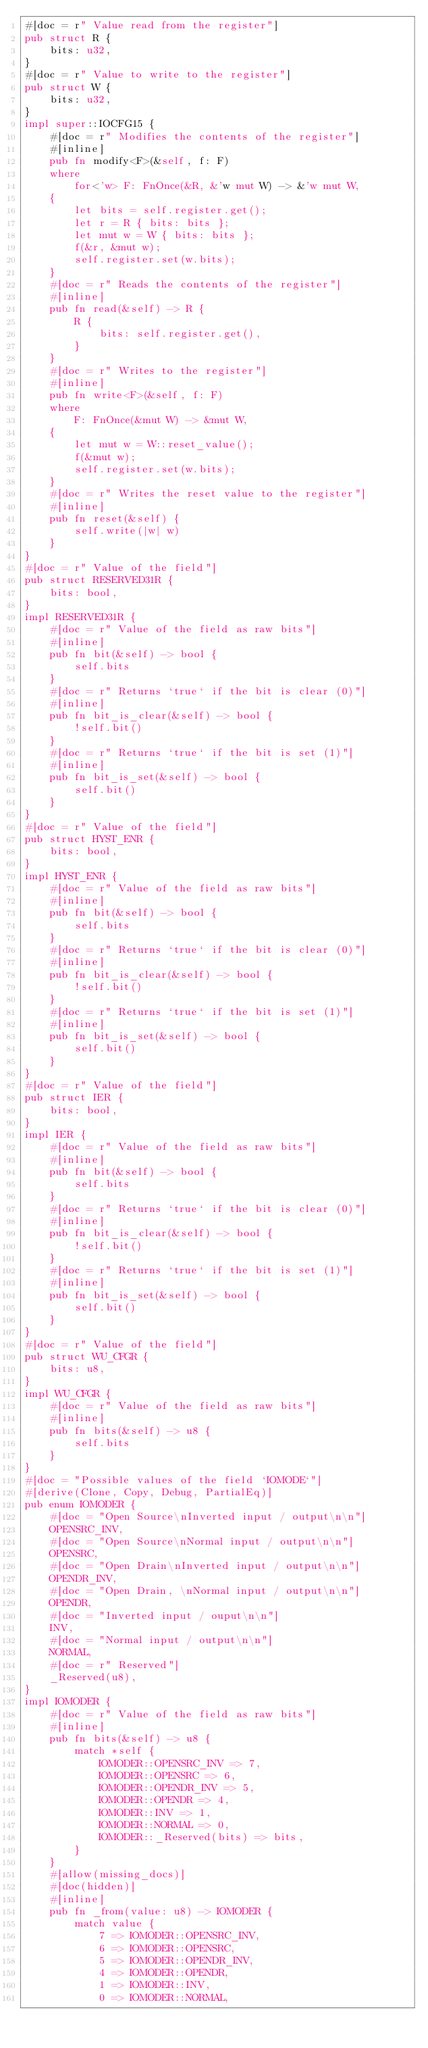<code> <loc_0><loc_0><loc_500><loc_500><_Rust_>#[doc = r" Value read from the register"]
pub struct R {
    bits: u32,
}
#[doc = r" Value to write to the register"]
pub struct W {
    bits: u32,
}
impl super::IOCFG15 {
    #[doc = r" Modifies the contents of the register"]
    #[inline]
    pub fn modify<F>(&self, f: F)
    where
        for<'w> F: FnOnce(&R, &'w mut W) -> &'w mut W,
    {
        let bits = self.register.get();
        let r = R { bits: bits };
        let mut w = W { bits: bits };
        f(&r, &mut w);
        self.register.set(w.bits);
    }
    #[doc = r" Reads the contents of the register"]
    #[inline]
    pub fn read(&self) -> R {
        R {
            bits: self.register.get(),
        }
    }
    #[doc = r" Writes to the register"]
    #[inline]
    pub fn write<F>(&self, f: F)
    where
        F: FnOnce(&mut W) -> &mut W,
    {
        let mut w = W::reset_value();
        f(&mut w);
        self.register.set(w.bits);
    }
    #[doc = r" Writes the reset value to the register"]
    #[inline]
    pub fn reset(&self) {
        self.write(|w| w)
    }
}
#[doc = r" Value of the field"]
pub struct RESERVED31R {
    bits: bool,
}
impl RESERVED31R {
    #[doc = r" Value of the field as raw bits"]
    #[inline]
    pub fn bit(&self) -> bool {
        self.bits
    }
    #[doc = r" Returns `true` if the bit is clear (0)"]
    #[inline]
    pub fn bit_is_clear(&self) -> bool {
        !self.bit()
    }
    #[doc = r" Returns `true` if the bit is set (1)"]
    #[inline]
    pub fn bit_is_set(&self) -> bool {
        self.bit()
    }
}
#[doc = r" Value of the field"]
pub struct HYST_ENR {
    bits: bool,
}
impl HYST_ENR {
    #[doc = r" Value of the field as raw bits"]
    #[inline]
    pub fn bit(&self) -> bool {
        self.bits
    }
    #[doc = r" Returns `true` if the bit is clear (0)"]
    #[inline]
    pub fn bit_is_clear(&self) -> bool {
        !self.bit()
    }
    #[doc = r" Returns `true` if the bit is set (1)"]
    #[inline]
    pub fn bit_is_set(&self) -> bool {
        self.bit()
    }
}
#[doc = r" Value of the field"]
pub struct IER {
    bits: bool,
}
impl IER {
    #[doc = r" Value of the field as raw bits"]
    #[inline]
    pub fn bit(&self) -> bool {
        self.bits
    }
    #[doc = r" Returns `true` if the bit is clear (0)"]
    #[inline]
    pub fn bit_is_clear(&self) -> bool {
        !self.bit()
    }
    #[doc = r" Returns `true` if the bit is set (1)"]
    #[inline]
    pub fn bit_is_set(&self) -> bool {
        self.bit()
    }
}
#[doc = r" Value of the field"]
pub struct WU_CFGR {
    bits: u8,
}
impl WU_CFGR {
    #[doc = r" Value of the field as raw bits"]
    #[inline]
    pub fn bits(&self) -> u8 {
        self.bits
    }
}
#[doc = "Possible values of the field `IOMODE`"]
#[derive(Clone, Copy, Debug, PartialEq)]
pub enum IOMODER {
    #[doc = "Open Source\nInverted input / output\n\n"]
    OPENSRC_INV,
    #[doc = "Open Source\nNormal input / output\n\n"]
    OPENSRC,
    #[doc = "Open Drain\nInverted input / output\n\n"]
    OPENDR_INV,
    #[doc = "Open Drain, \nNormal input / output\n\n"]
    OPENDR,
    #[doc = "Inverted input / ouput\n\n"]
    INV,
    #[doc = "Normal input / output\n\n"]
    NORMAL,
    #[doc = r" Reserved"]
    _Reserved(u8),
}
impl IOMODER {
    #[doc = r" Value of the field as raw bits"]
    #[inline]
    pub fn bits(&self) -> u8 {
        match *self {
            IOMODER::OPENSRC_INV => 7,
            IOMODER::OPENSRC => 6,
            IOMODER::OPENDR_INV => 5,
            IOMODER::OPENDR => 4,
            IOMODER::INV => 1,
            IOMODER::NORMAL => 0,
            IOMODER::_Reserved(bits) => bits,
        }
    }
    #[allow(missing_docs)]
    #[doc(hidden)]
    #[inline]
    pub fn _from(value: u8) -> IOMODER {
        match value {
            7 => IOMODER::OPENSRC_INV,
            6 => IOMODER::OPENSRC,
            5 => IOMODER::OPENDR_INV,
            4 => IOMODER::OPENDR,
            1 => IOMODER::INV,
            0 => IOMODER::NORMAL,</code> 